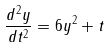<formula> <loc_0><loc_0><loc_500><loc_500>\frac { d ^ { 2 } y } { d t ^ { 2 } } = 6 y ^ { 2 } + t</formula> 